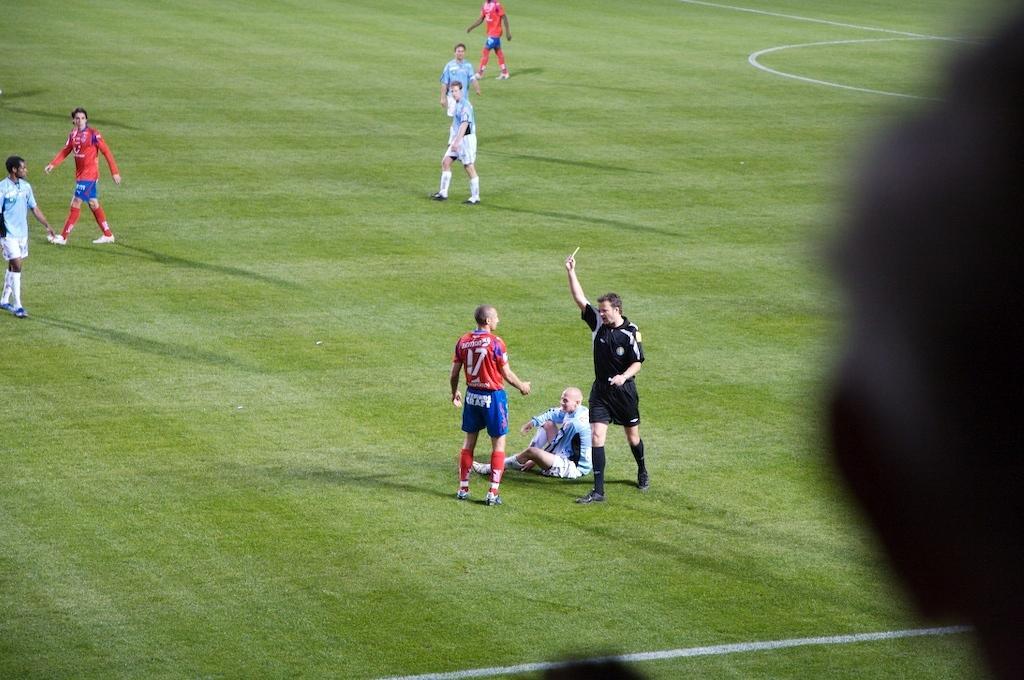How would you summarize this image in a sentence or two? In this image I can see grass ground and on it I can see white lines and few people. I can see three of them are wearing red colour dress, one is wearing black and rest all are wearing blue. I can also see shadows on ground. 